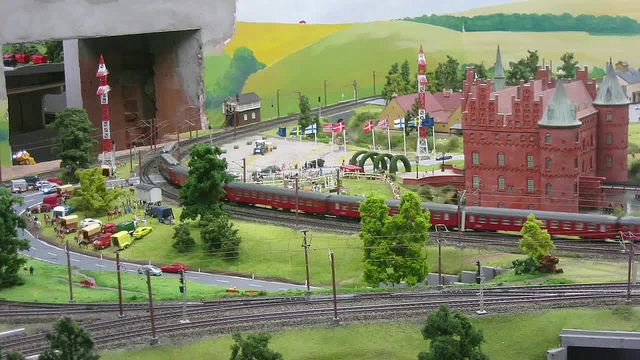How many trains are there? 1 